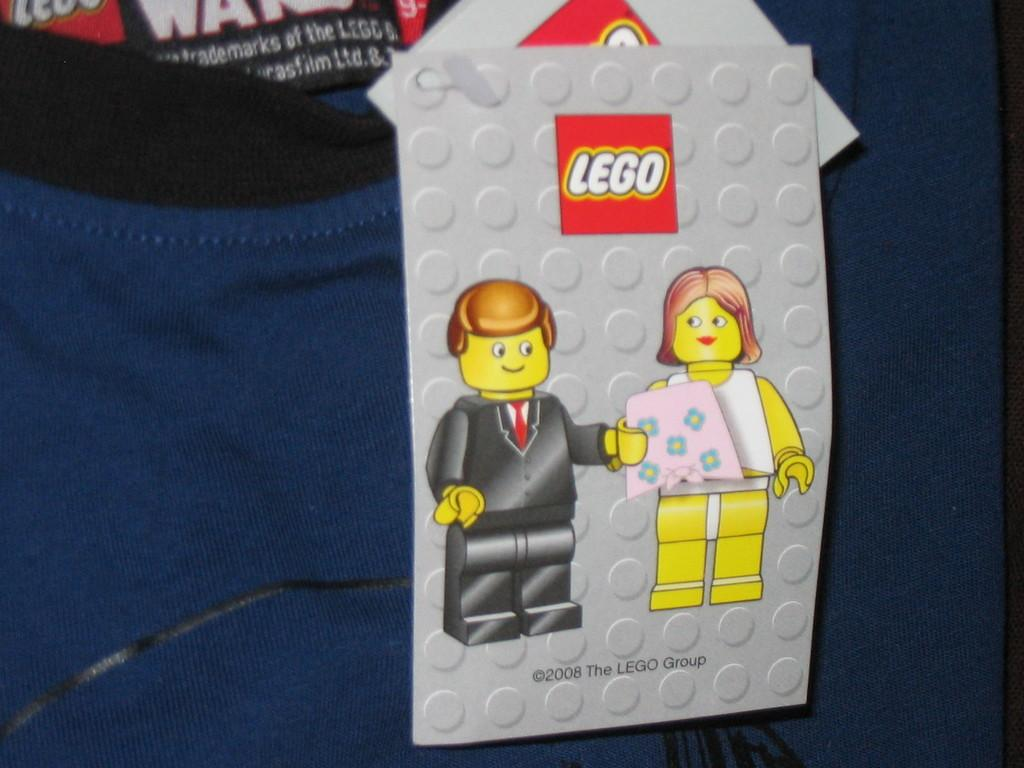What is the color of the t-shirt in the image? The t-shirt in the image is violet color. Are there any additional elements on the t-shirt? Yes, there are two gray color cards on the t-shirt. What can be seen on the first card? The first card has two animated images. Is there any other feature on the first card? Yes, the first card has a watermark. How many fingers can be seen on the t-shirt in the image? There are no fingers visible on the t-shirt in the image. What type of angle is depicted on the t-shirt? There is no angle depicted on the t-shirt in the image. 